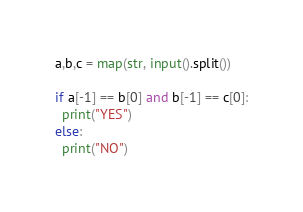Convert code to text. <code><loc_0><loc_0><loc_500><loc_500><_Python_>a,b,c = map(str, input().split())

if a[-1] == b[0] and b[-1] == c[0]:
  print("YES")
else:
  print("NO")</code> 